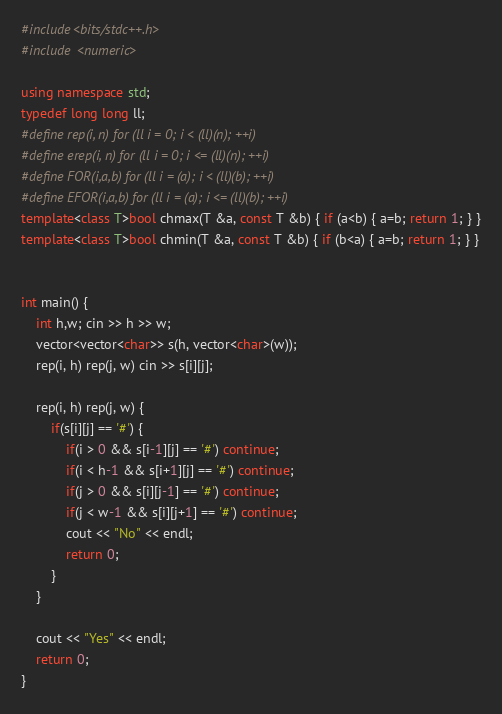Convert code to text. <code><loc_0><loc_0><loc_500><loc_500><_C++_>#include<bits/stdc++.h>
#include <numeric>

using namespace std;
typedef long long ll;
#define rep(i, n) for (ll i = 0; i < (ll)(n); ++i)
#define erep(i, n) for (ll i = 0; i <= (ll)(n); ++i)
#define FOR(i,a,b) for (ll i = (a); i < (ll)(b); ++i)
#define EFOR(i,a,b) for (ll i = (a); i <= (ll)(b); ++i)
template<class T>bool chmax(T &a, const T &b) { if (a<b) { a=b; return 1; } }
template<class T>bool chmin(T &a, const T &b) { if (b<a) { a=b; return 1; } }


int main() {
    int h,w; cin >> h >> w;
    vector<vector<char>> s(h, vector<char>(w));
    rep(i, h) rep(j, w) cin >> s[i][j];

    rep(i, h) rep(j, w) {
        if(s[i][j] == '#') {
            if(i > 0 && s[i-1][j] == '#') continue;
            if(i < h-1 && s[i+1][j] == '#') continue;
            if(j > 0 && s[i][j-1] == '#') continue;
            if(j < w-1 && s[i][j+1] == '#') continue;
            cout << "No" << endl;
            return 0;
        }
    }

    cout << "Yes" << endl;
    return 0;
}

</code> 